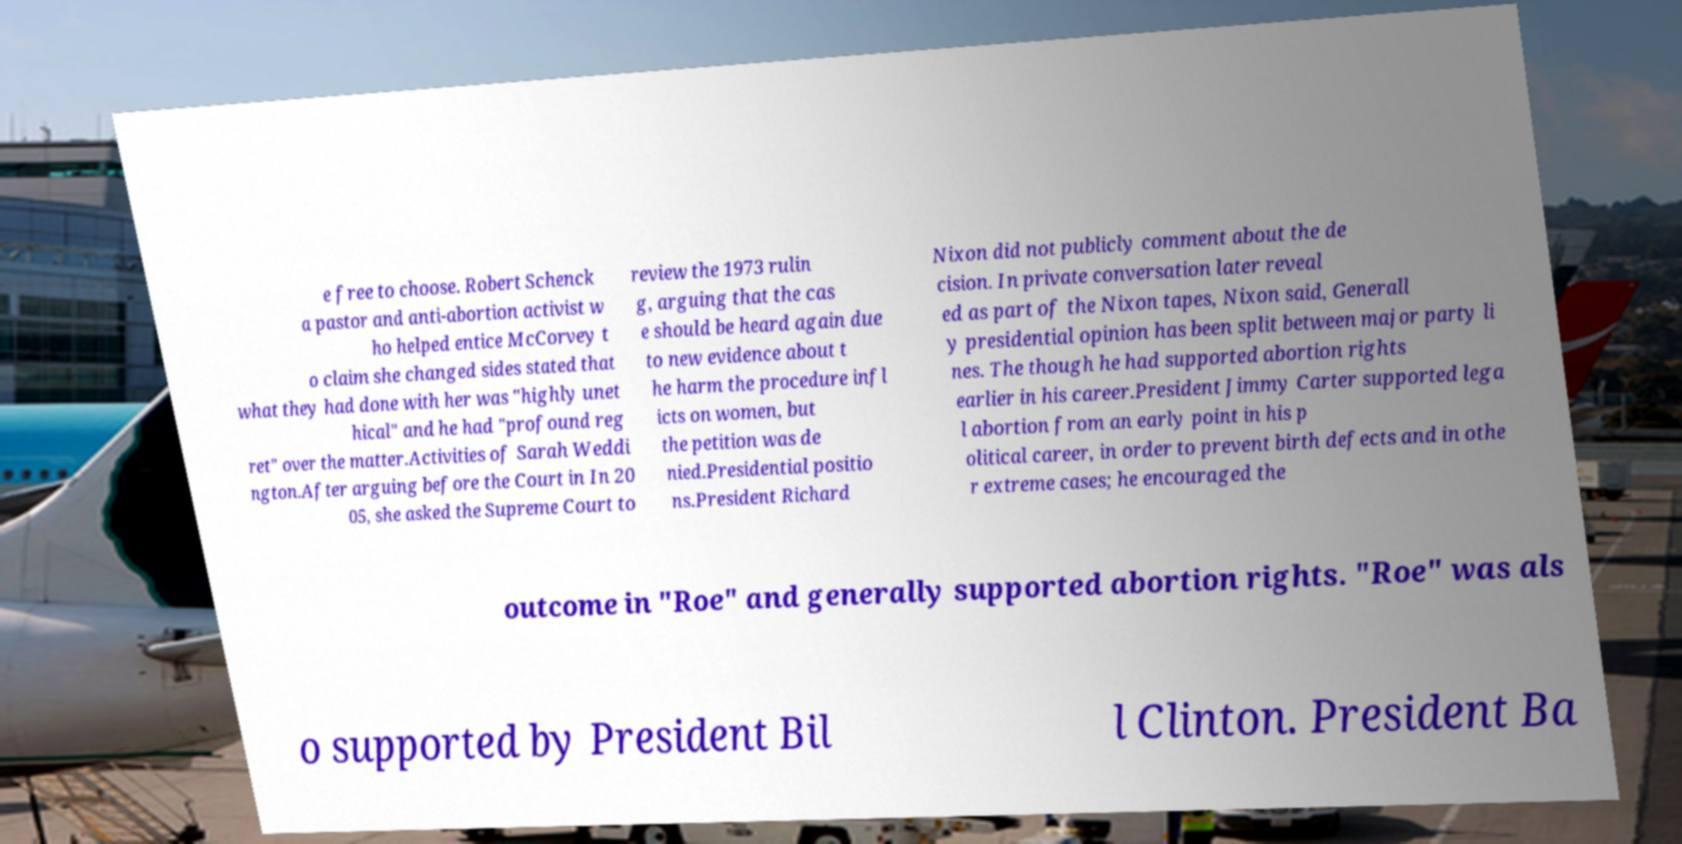There's text embedded in this image that I need extracted. Can you transcribe it verbatim? e free to choose. Robert Schenck a pastor and anti-abortion activist w ho helped entice McCorvey t o claim she changed sides stated that what they had done with her was "highly unet hical" and he had "profound reg ret" over the matter.Activities of Sarah Weddi ngton.After arguing before the Court in In 20 05, she asked the Supreme Court to review the 1973 rulin g, arguing that the cas e should be heard again due to new evidence about t he harm the procedure infl icts on women, but the petition was de nied.Presidential positio ns.President Richard Nixon did not publicly comment about the de cision. In private conversation later reveal ed as part of the Nixon tapes, Nixon said, Generall y presidential opinion has been split between major party li nes. The though he had supported abortion rights earlier in his career.President Jimmy Carter supported lega l abortion from an early point in his p olitical career, in order to prevent birth defects and in othe r extreme cases; he encouraged the outcome in "Roe" and generally supported abortion rights. "Roe" was als o supported by President Bil l Clinton. President Ba 